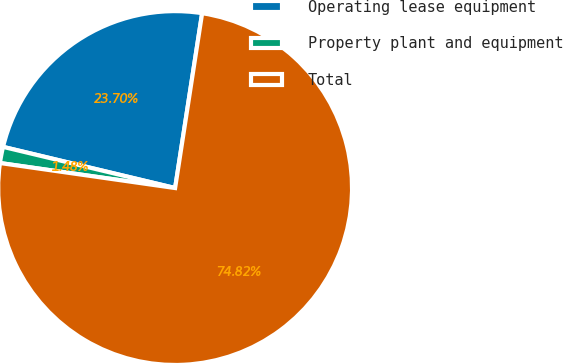Convert chart. <chart><loc_0><loc_0><loc_500><loc_500><pie_chart><fcel>Operating lease equipment<fcel>Property plant and equipment<fcel>Total<nl><fcel>23.7%<fcel>1.48%<fcel>74.81%<nl></chart> 